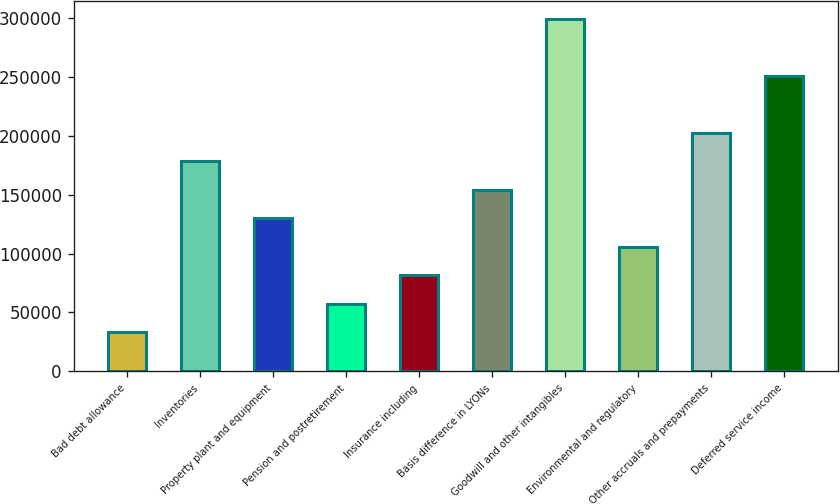Convert chart to OTSL. <chart><loc_0><loc_0><loc_500><loc_500><bar_chart><fcel>Bad debt allowance<fcel>Inventories<fcel>Property plant and equipment<fcel>Pension and postretirement<fcel>Insurance including<fcel>Basis difference in LYONs<fcel>Goodwill and other intangibles<fcel>Environmental and regulatory<fcel>Other accruals and prepayments<fcel>Deferred service income<nl><fcel>33072.3<fcel>178466<fcel>130002<fcel>57304.6<fcel>81536.9<fcel>154234<fcel>299628<fcel>105769<fcel>202698<fcel>251163<nl></chart> 